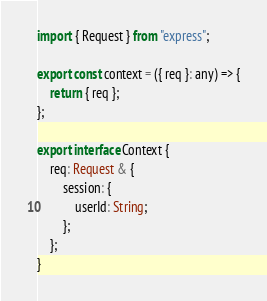Convert code to text. <code><loc_0><loc_0><loc_500><loc_500><_TypeScript_>import { Request } from "express";

export const context = ({ req }: any) => {
    return { req };
};

export interface Context {
    req: Request & {
        session: {
            userId: String;
        };
    };
}
</code> 